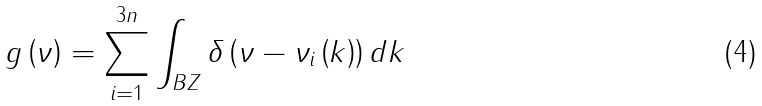<formula> <loc_0><loc_0><loc_500><loc_500>g \left ( \nu \right ) = \sum _ { i = 1 } ^ { 3 n } \int _ { B Z } \delta \left ( \nu - \nu _ { i } \left ( k \right ) \right ) d k</formula> 